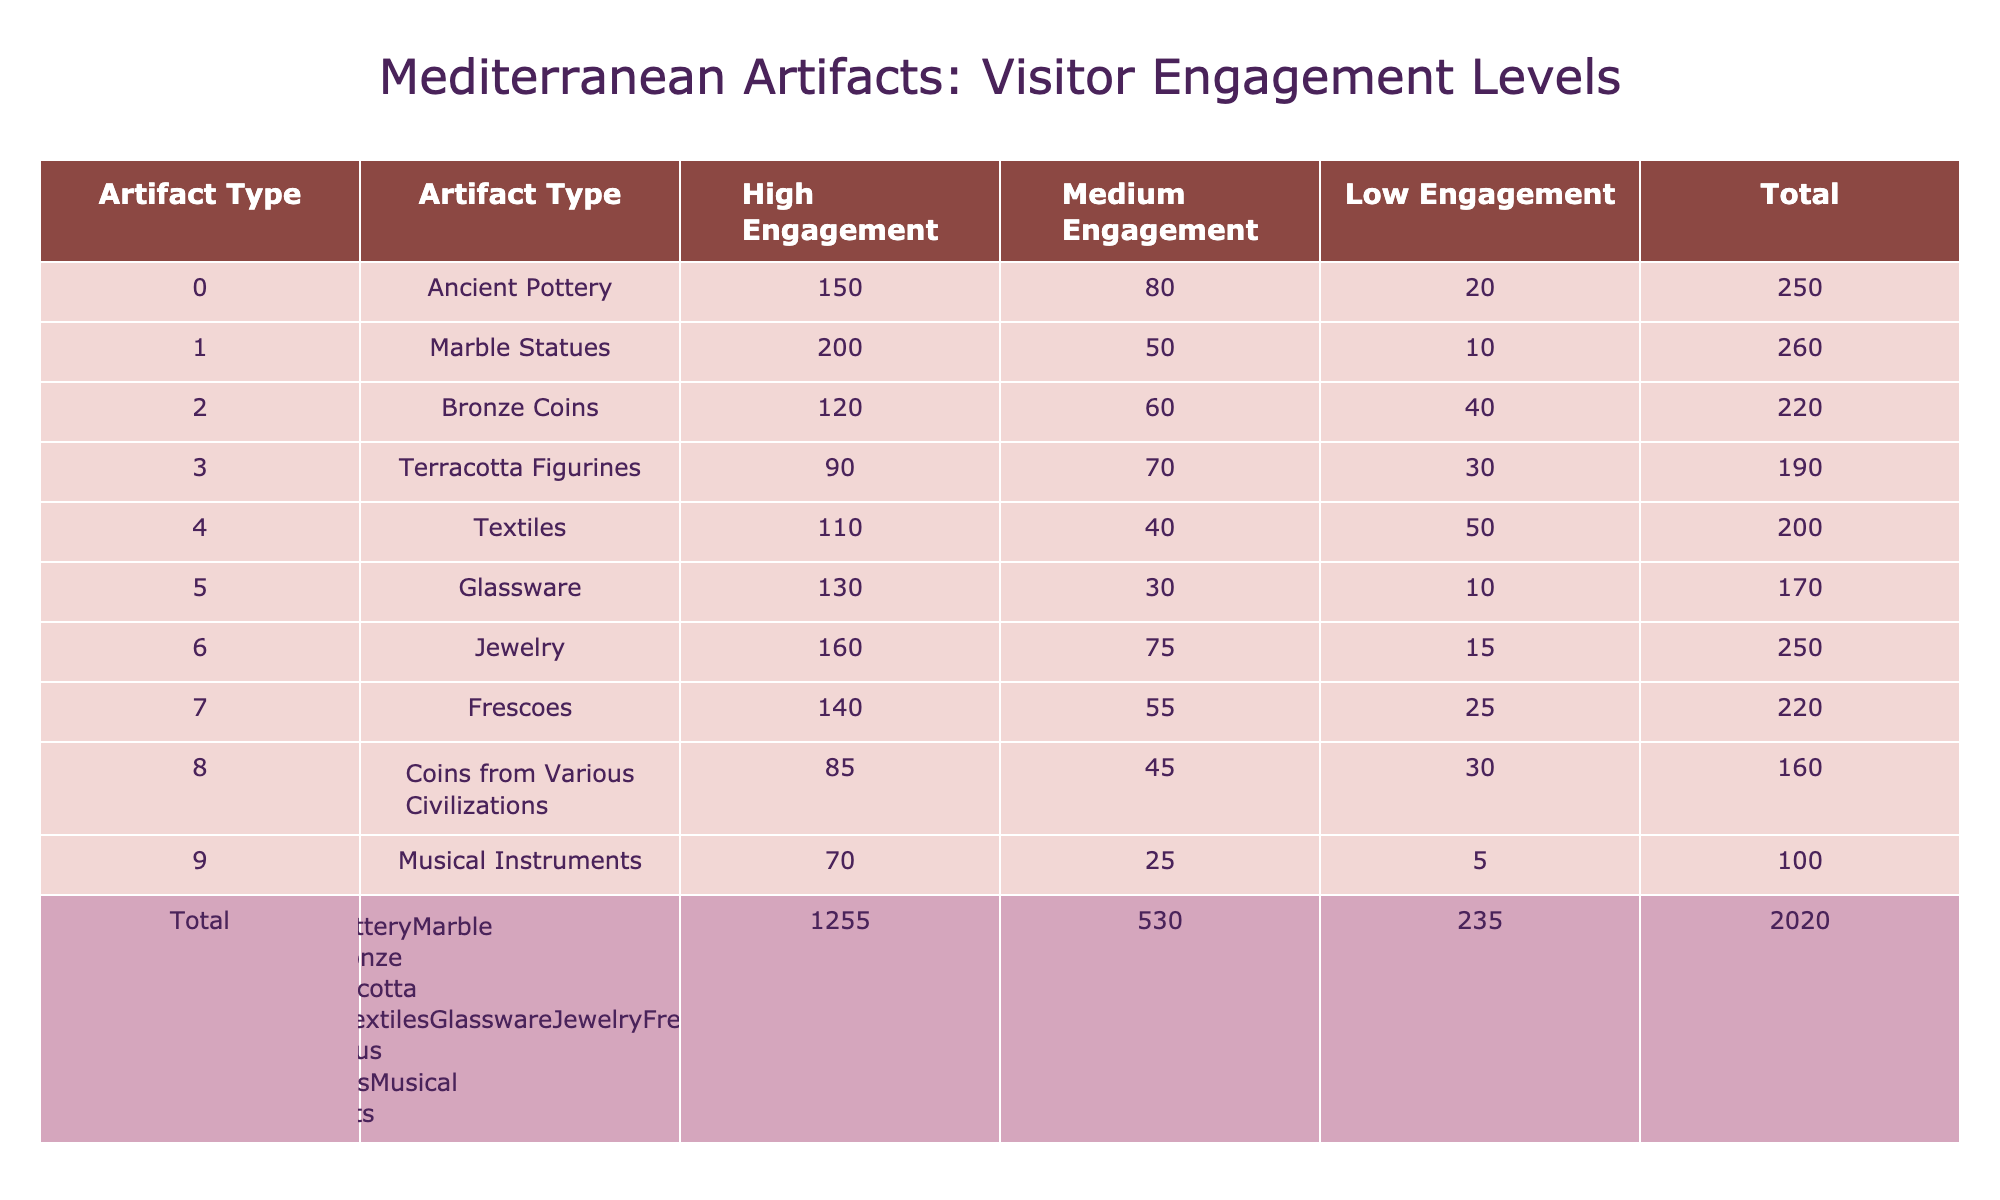What is the total number of visitors engaged with Ancient Pottery? The total number of visitors for Ancient Pottery can be found by adding the counts from all three engagement levels: High (150) + Medium (80) + Low (20) = 250.
Answer: 250 Which artifact type had the highest level of high engagement? Looking through the table, Marble Statues have the highest count in the High Engagement column with 200.
Answer: Marble Statues How many total artifacts displayed had a medium engagement level? To find the total number of artifacts with medium engagement, add the counts in the Medium Engagement column: 80 (Ancient Pottery) + 50 (Marble Statues) + 60 (Bronze Coins) + 70 (Terracotta Figurines) + 40 (Textiles) + 30 (Glassware) + 75 (Jewelry) + 55 (Frescoes) + 45 (Coins from Various Civilizations) + 25 (Musical Instruments) = 455.
Answer: 455 Are there more artifacts with low engagement compared to those with high engagement? To determine this, compare the total counts. High Engagement sums to 150 + 200 + 120 + 90 + 110 + 130 + 160 + 140 + 85 + 70 = 1,305. Low Engagement sums to 20 + 10 + 40 + 30 + 50 + 10 + 15 + 25 + 30 + 5 =  345. Since 1,305 > 345, there are indeed more artifacts with high engagement.
Answer: No What is the average number of visitors across all engagement levels for Jewelry? To find the average, sum up the engagement levels for Jewelry: High (160) + Medium (75) + Low (15) = 250. Divide by the number of engagement levels (3): 250/3 = approximately 83.33.
Answer: 83.33 Which artifact type has the lowest total visitor engagement? Calculate the total for each artifact type by adding the counts of all engagement levels. Musical Instruments have the lowest total: 70 (High) + 25 (Medium) + 5 (Low) = 100.
Answer: Musical Instruments What is the difference in high engagement visitors between Bronze Coins and Terracotta Figurines? High Engagement visitors are 120 (Bronze Coins) and 90 (Terracotta Figurines). The difference is calculated as 120 - 90 = 30.
Answer: 30 Which artifact type shows a pattern of low engagement across all levels? By analyzing the low engagement values for each type, Musical Instruments (5), Glassware (10), and Ancient Pottery (20) indicate lower engagement. Since Musical Instruments has the lowest values across all tiers, it can be said to show a low engagement pattern.
Answer: Musical Instruments 